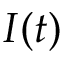Convert formula to latex. <formula><loc_0><loc_0><loc_500><loc_500>I ( t )</formula> 